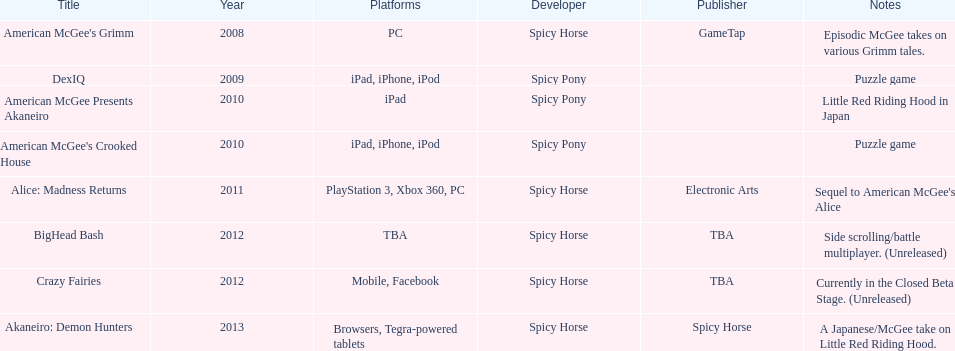Which title is exclusive to ipad and not for iphone or ipod? American McGee Presents Akaneiro. 